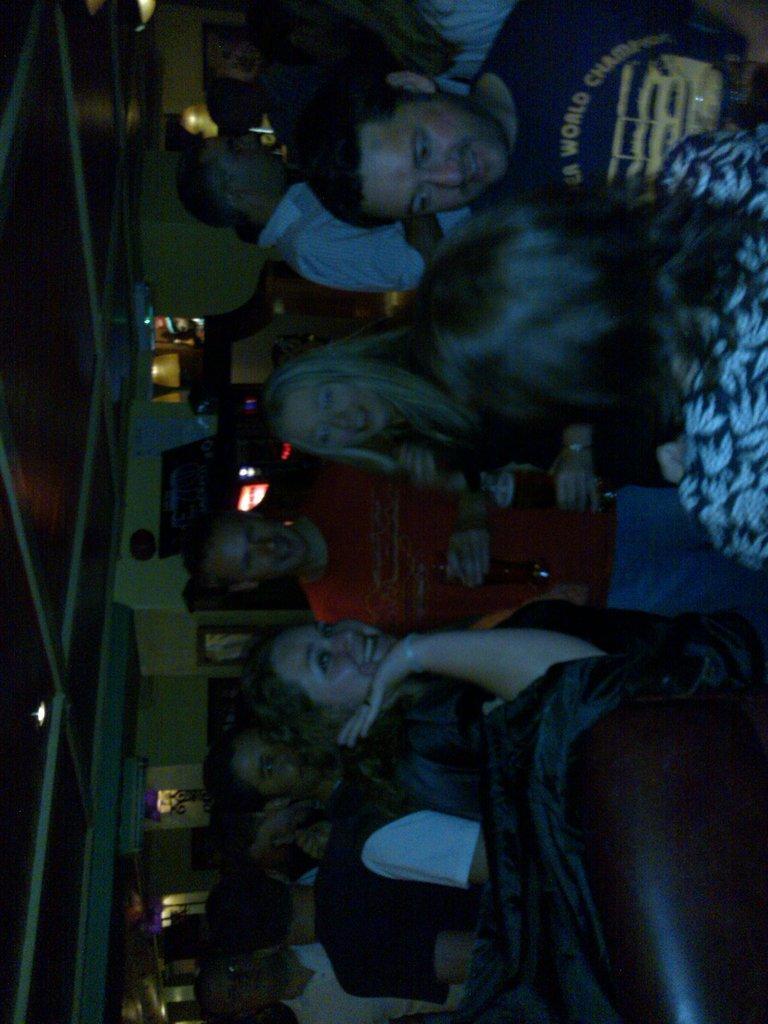Can you describe this image briefly? There are people and she is holding a glass and this man holding a bottle. In the background we can see wall and lights. At the top we can see light. 